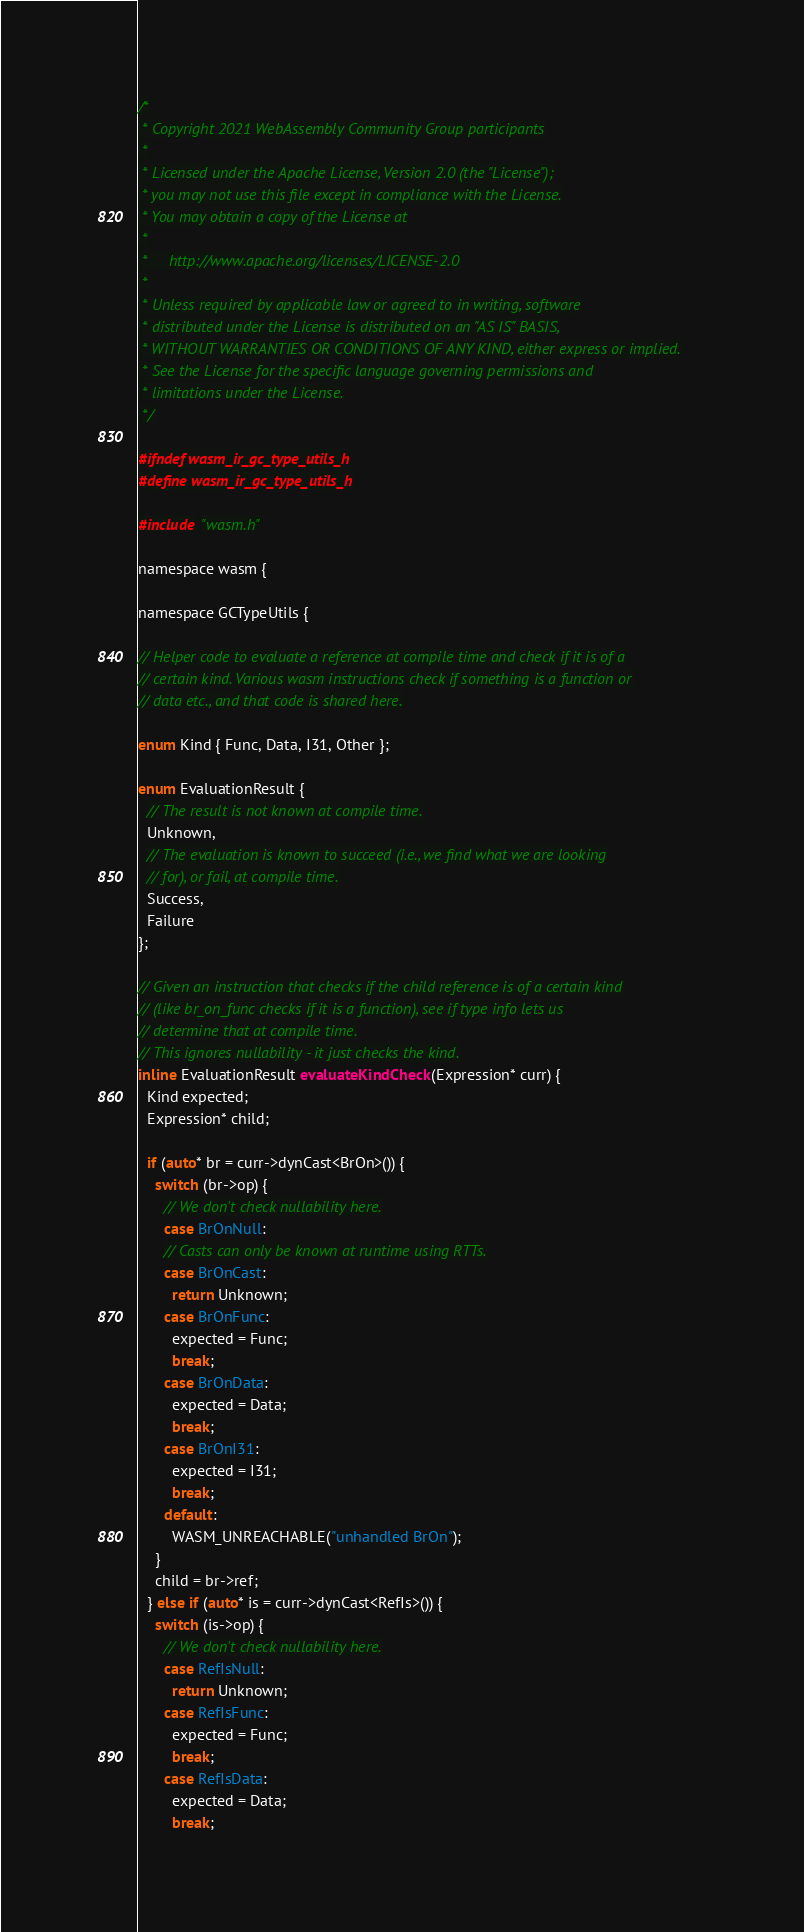Convert code to text. <code><loc_0><loc_0><loc_500><loc_500><_C_>/*
 * Copyright 2021 WebAssembly Community Group participants
 *
 * Licensed under the Apache License, Version 2.0 (the "License");
 * you may not use this file except in compliance with the License.
 * You may obtain a copy of the License at
 *
 *     http://www.apache.org/licenses/LICENSE-2.0
 *
 * Unless required by applicable law or agreed to in writing, software
 * distributed under the License is distributed on an "AS IS" BASIS,
 * WITHOUT WARRANTIES OR CONDITIONS OF ANY KIND, either express or implied.
 * See the License for the specific language governing permissions and
 * limitations under the License.
 */

#ifndef wasm_ir_gc_type_utils_h
#define wasm_ir_gc_type_utils_h

#include "wasm.h"

namespace wasm {

namespace GCTypeUtils {

// Helper code to evaluate a reference at compile time and check if it is of a
// certain kind. Various wasm instructions check if something is a function or
// data etc., and that code is shared here.

enum Kind { Func, Data, I31, Other };

enum EvaluationResult {
  // The result is not known at compile time.
  Unknown,
  // The evaluation is known to succeed (i.e., we find what we are looking
  // for), or fail, at compile time.
  Success,
  Failure
};

// Given an instruction that checks if the child reference is of a certain kind
// (like br_on_func checks if it is a function), see if type info lets us
// determine that at compile time.
// This ignores nullability - it just checks the kind.
inline EvaluationResult evaluateKindCheck(Expression* curr) {
  Kind expected;
  Expression* child;

  if (auto* br = curr->dynCast<BrOn>()) {
    switch (br->op) {
      // We don't check nullability here.
      case BrOnNull:
      // Casts can only be known at runtime using RTTs.
      case BrOnCast:
        return Unknown;
      case BrOnFunc:
        expected = Func;
        break;
      case BrOnData:
        expected = Data;
        break;
      case BrOnI31:
        expected = I31;
        break;
      default:
        WASM_UNREACHABLE("unhandled BrOn");
    }
    child = br->ref;
  } else if (auto* is = curr->dynCast<RefIs>()) {
    switch (is->op) {
      // We don't check nullability here.
      case RefIsNull:
        return Unknown;
      case RefIsFunc:
        expected = Func;
        break;
      case RefIsData:
        expected = Data;
        break;</code> 